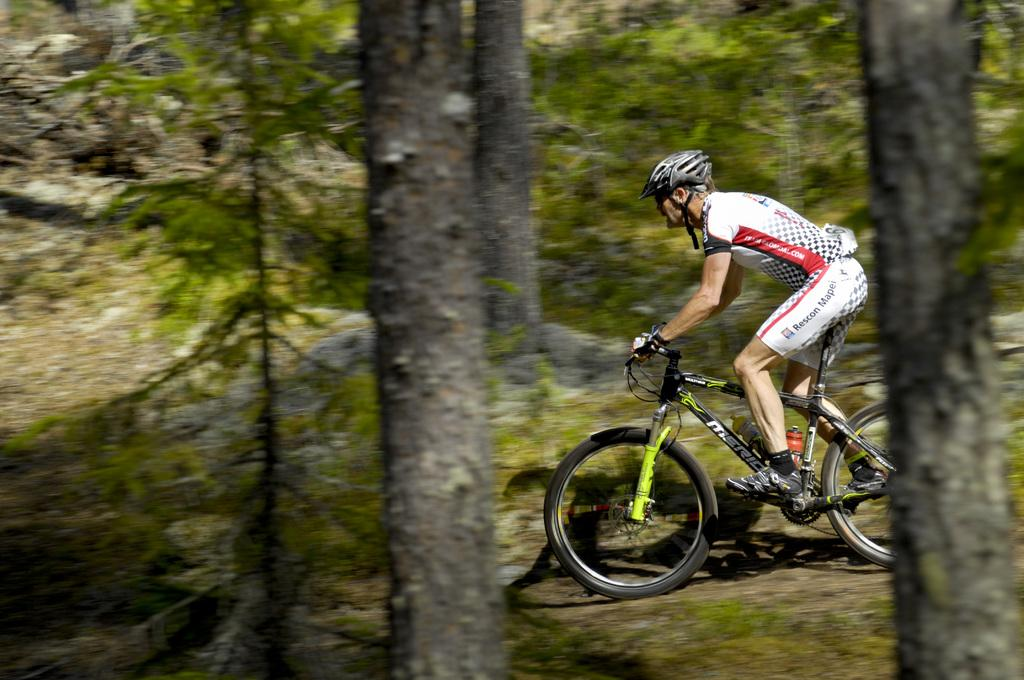What is the man in the image doing? The man is riding a bicycle in the image. What protective gear is the man wearing? The man is wearing a helmet, gloves, and shoes. What is the condition of the bicycle in the image? The bicycle is on the ground in the image. What can be seen in the background of the image? There are trees in the background of the image. Where is the nearest zoo in the image? There is no zoo present in the image. What type of mass is the man attending in the image? There is no mass or gathering depicted in the image; the man is simply riding a bicycle. 